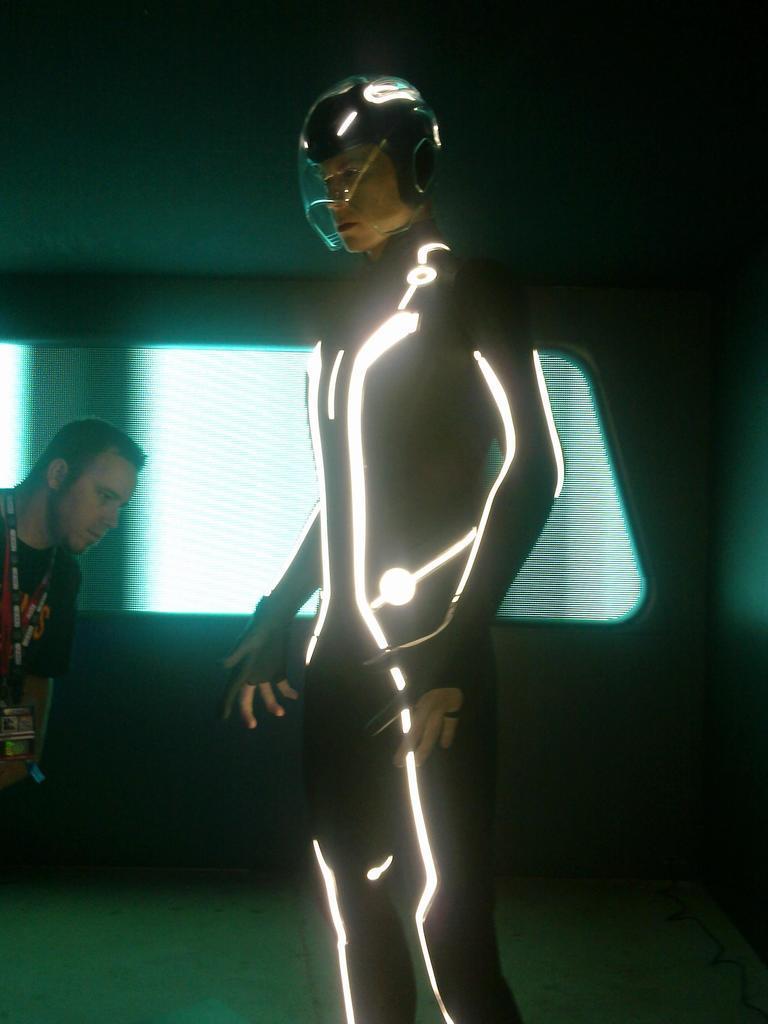In one or two sentences, can you explain what this image depicts? In this picture we can see a person in the fancy dress and on the left side of the person there is a man. Behind the people there is a wall. 